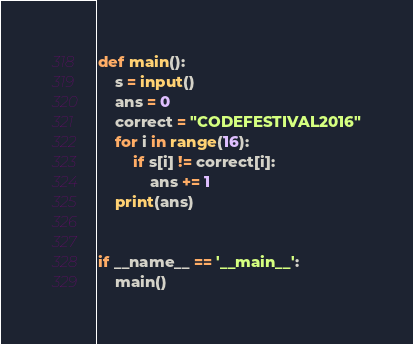Convert code to text. <code><loc_0><loc_0><loc_500><loc_500><_Python_>def main():
    s = input()
    ans = 0
    correct = "CODEFESTIVAL2016"
    for i in range(16):
        if s[i] != correct[i]:
            ans += 1
    print(ans)


if __name__ == '__main__':
    main()

</code> 